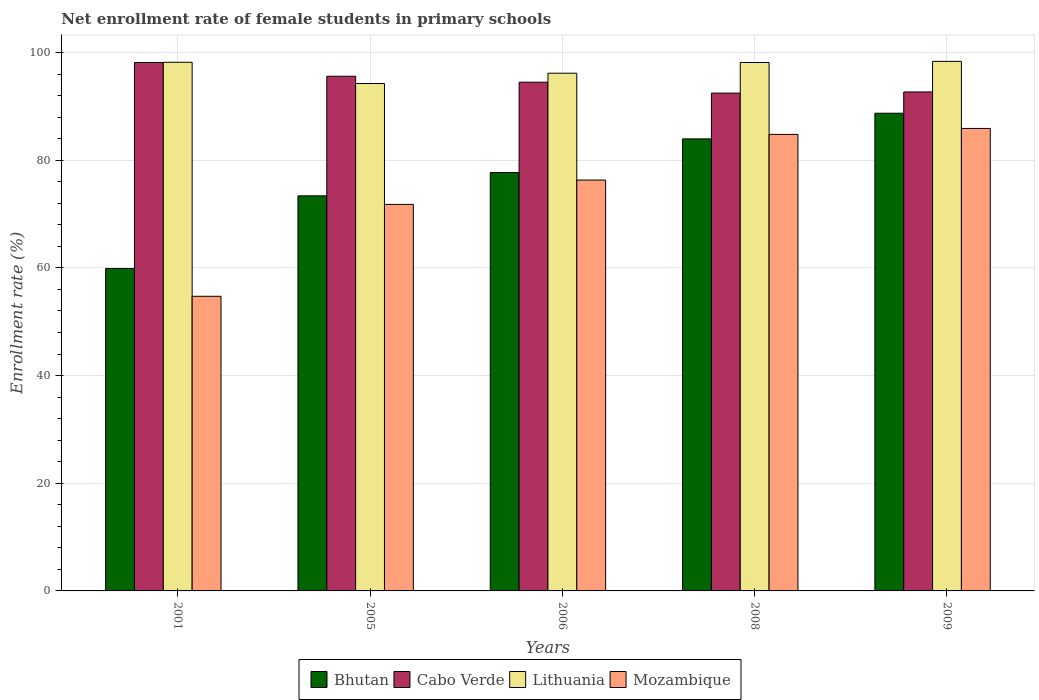How many groups of bars are there?
Provide a succinct answer. 5. What is the label of the 5th group of bars from the left?
Your response must be concise. 2009. What is the net enrollment rate of female students in primary schools in Bhutan in 2009?
Ensure brevity in your answer.  88.72. Across all years, what is the maximum net enrollment rate of female students in primary schools in Mozambique?
Your response must be concise. 85.89. Across all years, what is the minimum net enrollment rate of female students in primary schools in Mozambique?
Your answer should be very brief. 54.72. In which year was the net enrollment rate of female students in primary schools in Lithuania maximum?
Make the answer very short. 2009. In which year was the net enrollment rate of female students in primary schools in Cabo Verde minimum?
Your response must be concise. 2008. What is the total net enrollment rate of female students in primary schools in Mozambique in the graph?
Provide a succinct answer. 373.5. What is the difference between the net enrollment rate of female students in primary schools in Mozambique in 2001 and that in 2009?
Provide a short and direct response. -31.17. What is the difference between the net enrollment rate of female students in primary schools in Bhutan in 2009 and the net enrollment rate of female students in primary schools in Cabo Verde in 2006?
Your answer should be very brief. -5.76. What is the average net enrollment rate of female students in primary schools in Cabo Verde per year?
Provide a short and direct response. 94.67. In the year 2005, what is the difference between the net enrollment rate of female students in primary schools in Mozambique and net enrollment rate of female students in primary schools in Cabo Verde?
Give a very brief answer. -23.8. In how many years, is the net enrollment rate of female students in primary schools in Mozambique greater than 28 %?
Your response must be concise. 5. What is the ratio of the net enrollment rate of female students in primary schools in Cabo Verde in 2005 to that in 2008?
Keep it short and to the point. 1.03. Is the difference between the net enrollment rate of female students in primary schools in Mozambique in 2001 and 2006 greater than the difference between the net enrollment rate of female students in primary schools in Cabo Verde in 2001 and 2006?
Your answer should be compact. No. What is the difference between the highest and the second highest net enrollment rate of female students in primary schools in Bhutan?
Provide a succinct answer. 4.76. What is the difference between the highest and the lowest net enrollment rate of female students in primary schools in Mozambique?
Provide a short and direct response. 31.17. Is the sum of the net enrollment rate of female students in primary schools in Cabo Verde in 2001 and 2009 greater than the maximum net enrollment rate of female students in primary schools in Bhutan across all years?
Keep it short and to the point. Yes. What does the 2nd bar from the left in 2005 represents?
Offer a terse response. Cabo Verde. What does the 1st bar from the right in 2001 represents?
Make the answer very short. Mozambique. Are all the bars in the graph horizontal?
Offer a terse response. No. How many legend labels are there?
Your answer should be very brief. 4. How are the legend labels stacked?
Provide a short and direct response. Horizontal. What is the title of the graph?
Your answer should be compact. Net enrollment rate of female students in primary schools. Does "Croatia" appear as one of the legend labels in the graph?
Give a very brief answer. No. What is the label or title of the X-axis?
Offer a very short reply. Years. What is the label or title of the Y-axis?
Provide a succinct answer. Enrollment rate (%). What is the Enrollment rate (%) in Bhutan in 2001?
Provide a succinct answer. 59.88. What is the Enrollment rate (%) of Cabo Verde in 2001?
Give a very brief answer. 98.14. What is the Enrollment rate (%) of Lithuania in 2001?
Make the answer very short. 98.18. What is the Enrollment rate (%) in Mozambique in 2001?
Offer a very short reply. 54.72. What is the Enrollment rate (%) in Bhutan in 2005?
Your answer should be very brief. 73.38. What is the Enrollment rate (%) in Cabo Verde in 2005?
Give a very brief answer. 95.59. What is the Enrollment rate (%) of Lithuania in 2005?
Make the answer very short. 94.24. What is the Enrollment rate (%) of Mozambique in 2005?
Keep it short and to the point. 71.78. What is the Enrollment rate (%) of Bhutan in 2006?
Your response must be concise. 77.7. What is the Enrollment rate (%) of Cabo Verde in 2006?
Keep it short and to the point. 94.48. What is the Enrollment rate (%) in Lithuania in 2006?
Give a very brief answer. 96.15. What is the Enrollment rate (%) of Mozambique in 2006?
Your answer should be compact. 76.31. What is the Enrollment rate (%) of Bhutan in 2008?
Your response must be concise. 83.95. What is the Enrollment rate (%) of Cabo Verde in 2008?
Your answer should be very brief. 92.46. What is the Enrollment rate (%) in Lithuania in 2008?
Your answer should be compact. 98.14. What is the Enrollment rate (%) in Mozambique in 2008?
Offer a terse response. 84.79. What is the Enrollment rate (%) of Bhutan in 2009?
Provide a short and direct response. 88.72. What is the Enrollment rate (%) in Cabo Verde in 2009?
Provide a succinct answer. 92.67. What is the Enrollment rate (%) in Lithuania in 2009?
Offer a terse response. 98.35. What is the Enrollment rate (%) of Mozambique in 2009?
Make the answer very short. 85.89. Across all years, what is the maximum Enrollment rate (%) of Bhutan?
Ensure brevity in your answer.  88.72. Across all years, what is the maximum Enrollment rate (%) of Cabo Verde?
Provide a succinct answer. 98.14. Across all years, what is the maximum Enrollment rate (%) of Lithuania?
Your response must be concise. 98.35. Across all years, what is the maximum Enrollment rate (%) in Mozambique?
Keep it short and to the point. 85.89. Across all years, what is the minimum Enrollment rate (%) in Bhutan?
Keep it short and to the point. 59.88. Across all years, what is the minimum Enrollment rate (%) of Cabo Verde?
Offer a very short reply. 92.46. Across all years, what is the minimum Enrollment rate (%) of Lithuania?
Keep it short and to the point. 94.24. Across all years, what is the minimum Enrollment rate (%) in Mozambique?
Provide a succinct answer. 54.72. What is the total Enrollment rate (%) in Bhutan in the graph?
Offer a terse response. 383.63. What is the total Enrollment rate (%) in Cabo Verde in the graph?
Provide a succinct answer. 473.34. What is the total Enrollment rate (%) in Lithuania in the graph?
Your answer should be very brief. 485.06. What is the total Enrollment rate (%) in Mozambique in the graph?
Your response must be concise. 373.5. What is the difference between the Enrollment rate (%) in Bhutan in 2001 and that in 2005?
Offer a terse response. -13.5. What is the difference between the Enrollment rate (%) in Cabo Verde in 2001 and that in 2005?
Keep it short and to the point. 2.55. What is the difference between the Enrollment rate (%) in Lithuania in 2001 and that in 2005?
Keep it short and to the point. 3.94. What is the difference between the Enrollment rate (%) in Mozambique in 2001 and that in 2005?
Ensure brevity in your answer.  -17.06. What is the difference between the Enrollment rate (%) in Bhutan in 2001 and that in 2006?
Give a very brief answer. -17.82. What is the difference between the Enrollment rate (%) in Cabo Verde in 2001 and that in 2006?
Your response must be concise. 3.66. What is the difference between the Enrollment rate (%) in Lithuania in 2001 and that in 2006?
Keep it short and to the point. 2.03. What is the difference between the Enrollment rate (%) in Mozambique in 2001 and that in 2006?
Offer a very short reply. -21.59. What is the difference between the Enrollment rate (%) of Bhutan in 2001 and that in 2008?
Provide a short and direct response. -24.08. What is the difference between the Enrollment rate (%) in Cabo Verde in 2001 and that in 2008?
Provide a succinct answer. 5.68. What is the difference between the Enrollment rate (%) of Lithuania in 2001 and that in 2008?
Offer a terse response. 0.04. What is the difference between the Enrollment rate (%) of Mozambique in 2001 and that in 2008?
Offer a terse response. -30.07. What is the difference between the Enrollment rate (%) of Bhutan in 2001 and that in 2009?
Make the answer very short. -28.84. What is the difference between the Enrollment rate (%) of Cabo Verde in 2001 and that in 2009?
Ensure brevity in your answer.  5.47. What is the difference between the Enrollment rate (%) in Lithuania in 2001 and that in 2009?
Offer a terse response. -0.17. What is the difference between the Enrollment rate (%) in Mozambique in 2001 and that in 2009?
Your answer should be very brief. -31.17. What is the difference between the Enrollment rate (%) of Bhutan in 2005 and that in 2006?
Your response must be concise. -4.32. What is the difference between the Enrollment rate (%) in Cabo Verde in 2005 and that in 2006?
Your answer should be compact. 1.11. What is the difference between the Enrollment rate (%) of Lithuania in 2005 and that in 2006?
Keep it short and to the point. -1.91. What is the difference between the Enrollment rate (%) in Mozambique in 2005 and that in 2006?
Give a very brief answer. -4.52. What is the difference between the Enrollment rate (%) of Bhutan in 2005 and that in 2008?
Make the answer very short. -10.58. What is the difference between the Enrollment rate (%) of Cabo Verde in 2005 and that in 2008?
Ensure brevity in your answer.  3.13. What is the difference between the Enrollment rate (%) in Lithuania in 2005 and that in 2008?
Provide a short and direct response. -3.9. What is the difference between the Enrollment rate (%) of Mozambique in 2005 and that in 2008?
Your answer should be very brief. -13.01. What is the difference between the Enrollment rate (%) of Bhutan in 2005 and that in 2009?
Your answer should be very brief. -15.34. What is the difference between the Enrollment rate (%) in Cabo Verde in 2005 and that in 2009?
Your response must be concise. 2.91. What is the difference between the Enrollment rate (%) in Lithuania in 2005 and that in 2009?
Make the answer very short. -4.12. What is the difference between the Enrollment rate (%) in Mozambique in 2005 and that in 2009?
Offer a terse response. -14.11. What is the difference between the Enrollment rate (%) in Bhutan in 2006 and that in 2008?
Give a very brief answer. -6.25. What is the difference between the Enrollment rate (%) in Cabo Verde in 2006 and that in 2008?
Make the answer very short. 2.02. What is the difference between the Enrollment rate (%) of Lithuania in 2006 and that in 2008?
Provide a short and direct response. -1.99. What is the difference between the Enrollment rate (%) of Mozambique in 2006 and that in 2008?
Your answer should be compact. -8.48. What is the difference between the Enrollment rate (%) of Bhutan in 2006 and that in 2009?
Make the answer very short. -11.02. What is the difference between the Enrollment rate (%) of Cabo Verde in 2006 and that in 2009?
Give a very brief answer. 1.81. What is the difference between the Enrollment rate (%) of Lithuania in 2006 and that in 2009?
Keep it short and to the point. -2.2. What is the difference between the Enrollment rate (%) of Mozambique in 2006 and that in 2009?
Ensure brevity in your answer.  -9.59. What is the difference between the Enrollment rate (%) of Bhutan in 2008 and that in 2009?
Keep it short and to the point. -4.76. What is the difference between the Enrollment rate (%) in Cabo Verde in 2008 and that in 2009?
Provide a succinct answer. -0.22. What is the difference between the Enrollment rate (%) of Lithuania in 2008 and that in 2009?
Your response must be concise. -0.21. What is the difference between the Enrollment rate (%) in Mozambique in 2008 and that in 2009?
Keep it short and to the point. -1.1. What is the difference between the Enrollment rate (%) of Bhutan in 2001 and the Enrollment rate (%) of Cabo Verde in 2005?
Make the answer very short. -35.71. What is the difference between the Enrollment rate (%) of Bhutan in 2001 and the Enrollment rate (%) of Lithuania in 2005?
Your answer should be very brief. -34.36. What is the difference between the Enrollment rate (%) of Bhutan in 2001 and the Enrollment rate (%) of Mozambique in 2005?
Keep it short and to the point. -11.91. What is the difference between the Enrollment rate (%) in Cabo Verde in 2001 and the Enrollment rate (%) in Lithuania in 2005?
Provide a succinct answer. 3.9. What is the difference between the Enrollment rate (%) in Cabo Verde in 2001 and the Enrollment rate (%) in Mozambique in 2005?
Your response must be concise. 26.36. What is the difference between the Enrollment rate (%) of Lithuania in 2001 and the Enrollment rate (%) of Mozambique in 2005?
Your answer should be very brief. 26.4. What is the difference between the Enrollment rate (%) of Bhutan in 2001 and the Enrollment rate (%) of Cabo Verde in 2006?
Offer a very short reply. -34.6. What is the difference between the Enrollment rate (%) of Bhutan in 2001 and the Enrollment rate (%) of Lithuania in 2006?
Your answer should be compact. -36.27. What is the difference between the Enrollment rate (%) in Bhutan in 2001 and the Enrollment rate (%) in Mozambique in 2006?
Offer a terse response. -16.43. What is the difference between the Enrollment rate (%) of Cabo Verde in 2001 and the Enrollment rate (%) of Lithuania in 2006?
Your response must be concise. 1.99. What is the difference between the Enrollment rate (%) of Cabo Verde in 2001 and the Enrollment rate (%) of Mozambique in 2006?
Ensure brevity in your answer.  21.83. What is the difference between the Enrollment rate (%) in Lithuania in 2001 and the Enrollment rate (%) in Mozambique in 2006?
Provide a short and direct response. 21.87. What is the difference between the Enrollment rate (%) in Bhutan in 2001 and the Enrollment rate (%) in Cabo Verde in 2008?
Provide a succinct answer. -32.58. What is the difference between the Enrollment rate (%) of Bhutan in 2001 and the Enrollment rate (%) of Lithuania in 2008?
Offer a very short reply. -38.26. What is the difference between the Enrollment rate (%) of Bhutan in 2001 and the Enrollment rate (%) of Mozambique in 2008?
Your response must be concise. -24.91. What is the difference between the Enrollment rate (%) of Cabo Verde in 2001 and the Enrollment rate (%) of Lithuania in 2008?
Your response must be concise. -0. What is the difference between the Enrollment rate (%) in Cabo Verde in 2001 and the Enrollment rate (%) in Mozambique in 2008?
Your answer should be very brief. 13.35. What is the difference between the Enrollment rate (%) of Lithuania in 2001 and the Enrollment rate (%) of Mozambique in 2008?
Ensure brevity in your answer.  13.39. What is the difference between the Enrollment rate (%) of Bhutan in 2001 and the Enrollment rate (%) of Cabo Verde in 2009?
Your answer should be compact. -32.8. What is the difference between the Enrollment rate (%) in Bhutan in 2001 and the Enrollment rate (%) in Lithuania in 2009?
Offer a terse response. -38.48. What is the difference between the Enrollment rate (%) in Bhutan in 2001 and the Enrollment rate (%) in Mozambique in 2009?
Ensure brevity in your answer.  -26.02. What is the difference between the Enrollment rate (%) of Cabo Verde in 2001 and the Enrollment rate (%) of Lithuania in 2009?
Your response must be concise. -0.21. What is the difference between the Enrollment rate (%) in Cabo Verde in 2001 and the Enrollment rate (%) in Mozambique in 2009?
Provide a succinct answer. 12.25. What is the difference between the Enrollment rate (%) of Lithuania in 2001 and the Enrollment rate (%) of Mozambique in 2009?
Provide a succinct answer. 12.29. What is the difference between the Enrollment rate (%) of Bhutan in 2005 and the Enrollment rate (%) of Cabo Verde in 2006?
Your answer should be very brief. -21.1. What is the difference between the Enrollment rate (%) in Bhutan in 2005 and the Enrollment rate (%) in Lithuania in 2006?
Your response must be concise. -22.77. What is the difference between the Enrollment rate (%) of Bhutan in 2005 and the Enrollment rate (%) of Mozambique in 2006?
Make the answer very short. -2.93. What is the difference between the Enrollment rate (%) of Cabo Verde in 2005 and the Enrollment rate (%) of Lithuania in 2006?
Give a very brief answer. -0.56. What is the difference between the Enrollment rate (%) in Cabo Verde in 2005 and the Enrollment rate (%) in Mozambique in 2006?
Make the answer very short. 19.28. What is the difference between the Enrollment rate (%) in Lithuania in 2005 and the Enrollment rate (%) in Mozambique in 2006?
Provide a short and direct response. 17.93. What is the difference between the Enrollment rate (%) of Bhutan in 2005 and the Enrollment rate (%) of Cabo Verde in 2008?
Ensure brevity in your answer.  -19.08. What is the difference between the Enrollment rate (%) in Bhutan in 2005 and the Enrollment rate (%) in Lithuania in 2008?
Keep it short and to the point. -24.76. What is the difference between the Enrollment rate (%) of Bhutan in 2005 and the Enrollment rate (%) of Mozambique in 2008?
Give a very brief answer. -11.41. What is the difference between the Enrollment rate (%) of Cabo Verde in 2005 and the Enrollment rate (%) of Lithuania in 2008?
Your answer should be very brief. -2.55. What is the difference between the Enrollment rate (%) of Cabo Verde in 2005 and the Enrollment rate (%) of Mozambique in 2008?
Provide a succinct answer. 10.8. What is the difference between the Enrollment rate (%) in Lithuania in 2005 and the Enrollment rate (%) in Mozambique in 2008?
Your answer should be very brief. 9.45. What is the difference between the Enrollment rate (%) in Bhutan in 2005 and the Enrollment rate (%) in Cabo Verde in 2009?
Your answer should be very brief. -19.3. What is the difference between the Enrollment rate (%) in Bhutan in 2005 and the Enrollment rate (%) in Lithuania in 2009?
Give a very brief answer. -24.98. What is the difference between the Enrollment rate (%) of Bhutan in 2005 and the Enrollment rate (%) of Mozambique in 2009?
Provide a succinct answer. -12.51. What is the difference between the Enrollment rate (%) in Cabo Verde in 2005 and the Enrollment rate (%) in Lithuania in 2009?
Give a very brief answer. -2.77. What is the difference between the Enrollment rate (%) in Cabo Verde in 2005 and the Enrollment rate (%) in Mozambique in 2009?
Offer a very short reply. 9.7. What is the difference between the Enrollment rate (%) of Lithuania in 2005 and the Enrollment rate (%) of Mozambique in 2009?
Provide a succinct answer. 8.35. What is the difference between the Enrollment rate (%) in Bhutan in 2006 and the Enrollment rate (%) in Cabo Verde in 2008?
Make the answer very short. -14.75. What is the difference between the Enrollment rate (%) in Bhutan in 2006 and the Enrollment rate (%) in Lithuania in 2008?
Offer a terse response. -20.44. What is the difference between the Enrollment rate (%) of Bhutan in 2006 and the Enrollment rate (%) of Mozambique in 2008?
Give a very brief answer. -7.09. What is the difference between the Enrollment rate (%) in Cabo Verde in 2006 and the Enrollment rate (%) in Lithuania in 2008?
Keep it short and to the point. -3.66. What is the difference between the Enrollment rate (%) in Cabo Verde in 2006 and the Enrollment rate (%) in Mozambique in 2008?
Your answer should be very brief. 9.69. What is the difference between the Enrollment rate (%) in Lithuania in 2006 and the Enrollment rate (%) in Mozambique in 2008?
Offer a terse response. 11.36. What is the difference between the Enrollment rate (%) of Bhutan in 2006 and the Enrollment rate (%) of Cabo Verde in 2009?
Keep it short and to the point. -14.97. What is the difference between the Enrollment rate (%) of Bhutan in 2006 and the Enrollment rate (%) of Lithuania in 2009?
Your response must be concise. -20.65. What is the difference between the Enrollment rate (%) in Bhutan in 2006 and the Enrollment rate (%) in Mozambique in 2009?
Your response must be concise. -8.19. What is the difference between the Enrollment rate (%) of Cabo Verde in 2006 and the Enrollment rate (%) of Lithuania in 2009?
Offer a terse response. -3.87. What is the difference between the Enrollment rate (%) in Cabo Verde in 2006 and the Enrollment rate (%) in Mozambique in 2009?
Make the answer very short. 8.59. What is the difference between the Enrollment rate (%) in Lithuania in 2006 and the Enrollment rate (%) in Mozambique in 2009?
Provide a succinct answer. 10.26. What is the difference between the Enrollment rate (%) in Bhutan in 2008 and the Enrollment rate (%) in Cabo Verde in 2009?
Provide a succinct answer. -8.72. What is the difference between the Enrollment rate (%) of Bhutan in 2008 and the Enrollment rate (%) of Lithuania in 2009?
Provide a short and direct response. -14.4. What is the difference between the Enrollment rate (%) in Bhutan in 2008 and the Enrollment rate (%) in Mozambique in 2009?
Your response must be concise. -1.94. What is the difference between the Enrollment rate (%) of Cabo Verde in 2008 and the Enrollment rate (%) of Lithuania in 2009?
Provide a short and direct response. -5.9. What is the difference between the Enrollment rate (%) of Cabo Verde in 2008 and the Enrollment rate (%) of Mozambique in 2009?
Your response must be concise. 6.56. What is the difference between the Enrollment rate (%) in Lithuania in 2008 and the Enrollment rate (%) in Mozambique in 2009?
Your response must be concise. 12.25. What is the average Enrollment rate (%) in Bhutan per year?
Provide a succinct answer. 76.73. What is the average Enrollment rate (%) of Cabo Verde per year?
Offer a very short reply. 94.67. What is the average Enrollment rate (%) in Lithuania per year?
Offer a very short reply. 97.01. What is the average Enrollment rate (%) in Mozambique per year?
Provide a short and direct response. 74.7. In the year 2001, what is the difference between the Enrollment rate (%) of Bhutan and Enrollment rate (%) of Cabo Verde?
Offer a very short reply. -38.26. In the year 2001, what is the difference between the Enrollment rate (%) in Bhutan and Enrollment rate (%) in Lithuania?
Offer a terse response. -38.3. In the year 2001, what is the difference between the Enrollment rate (%) of Bhutan and Enrollment rate (%) of Mozambique?
Provide a succinct answer. 5.16. In the year 2001, what is the difference between the Enrollment rate (%) in Cabo Verde and Enrollment rate (%) in Lithuania?
Keep it short and to the point. -0.04. In the year 2001, what is the difference between the Enrollment rate (%) of Cabo Verde and Enrollment rate (%) of Mozambique?
Offer a terse response. 43.42. In the year 2001, what is the difference between the Enrollment rate (%) of Lithuania and Enrollment rate (%) of Mozambique?
Provide a succinct answer. 43.46. In the year 2005, what is the difference between the Enrollment rate (%) of Bhutan and Enrollment rate (%) of Cabo Verde?
Keep it short and to the point. -22.21. In the year 2005, what is the difference between the Enrollment rate (%) in Bhutan and Enrollment rate (%) in Lithuania?
Ensure brevity in your answer.  -20.86. In the year 2005, what is the difference between the Enrollment rate (%) of Bhutan and Enrollment rate (%) of Mozambique?
Keep it short and to the point. 1.59. In the year 2005, what is the difference between the Enrollment rate (%) in Cabo Verde and Enrollment rate (%) in Lithuania?
Offer a very short reply. 1.35. In the year 2005, what is the difference between the Enrollment rate (%) of Cabo Verde and Enrollment rate (%) of Mozambique?
Offer a very short reply. 23.8. In the year 2005, what is the difference between the Enrollment rate (%) in Lithuania and Enrollment rate (%) in Mozambique?
Keep it short and to the point. 22.45. In the year 2006, what is the difference between the Enrollment rate (%) in Bhutan and Enrollment rate (%) in Cabo Verde?
Provide a succinct answer. -16.78. In the year 2006, what is the difference between the Enrollment rate (%) in Bhutan and Enrollment rate (%) in Lithuania?
Your response must be concise. -18.45. In the year 2006, what is the difference between the Enrollment rate (%) in Bhutan and Enrollment rate (%) in Mozambique?
Provide a short and direct response. 1.39. In the year 2006, what is the difference between the Enrollment rate (%) of Cabo Verde and Enrollment rate (%) of Lithuania?
Ensure brevity in your answer.  -1.67. In the year 2006, what is the difference between the Enrollment rate (%) in Cabo Verde and Enrollment rate (%) in Mozambique?
Your answer should be compact. 18.17. In the year 2006, what is the difference between the Enrollment rate (%) of Lithuania and Enrollment rate (%) of Mozambique?
Provide a succinct answer. 19.84. In the year 2008, what is the difference between the Enrollment rate (%) in Bhutan and Enrollment rate (%) in Cabo Verde?
Your answer should be very brief. -8.5. In the year 2008, what is the difference between the Enrollment rate (%) of Bhutan and Enrollment rate (%) of Lithuania?
Keep it short and to the point. -14.19. In the year 2008, what is the difference between the Enrollment rate (%) in Bhutan and Enrollment rate (%) in Mozambique?
Give a very brief answer. -0.83. In the year 2008, what is the difference between the Enrollment rate (%) of Cabo Verde and Enrollment rate (%) of Lithuania?
Keep it short and to the point. -5.68. In the year 2008, what is the difference between the Enrollment rate (%) of Cabo Verde and Enrollment rate (%) of Mozambique?
Keep it short and to the point. 7.67. In the year 2008, what is the difference between the Enrollment rate (%) of Lithuania and Enrollment rate (%) of Mozambique?
Offer a terse response. 13.35. In the year 2009, what is the difference between the Enrollment rate (%) in Bhutan and Enrollment rate (%) in Cabo Verde?
Provide a succinct answer. -3.95. In the year 2009, what is the difference between the Enrollment rate (%) in Bhutan and Enrollment rate (%) in Lithuania?
Your answer should be compact. -9.63. In the year 2009, what is the difference between the Enrollment rate (%) in Bhutan and Enrollment rate (%) in Mozambique?
Provide a succinct answer. 2.83. In the year 2009, what is the difference between the Enrollment rate (%) of Cabo Verde and Enrollment rate (%) of Lithuania?
Keep it short and to the point. -5.68. In the year 2009, what is the difference between the Enrollment rate (%) of Cabo Verde and Enrollment rate (%) of Mozambique?
Offer a very short reply. 6.78. In the year 2009, what is the difference between the Enrollment rate (%) of Lithuania and Enrollment rate (%) of Mozambique?
Offer a terse response. 12.46. What is the ratio of the Enrollment rate (%) in Bhutan in 2001 to that in 2005?
Offer a very short reply. 0.82. What is the ratio of the Enrollment rate (%) of Cabo Verde in 2001 to that in 2005?
Your answer should be very brief. 1.03. What is the ratio of the Enrollment rate (%) in Lithuania in 2001 to that in 2005?
Provide a short and direct response. 1.04. What is the ratio of the Enrollment rate (%) in Mozambique in 2001 to that in 2005?
Provide a short and direct response. 0.76. What is the ratio of the Enrollment rate (%) of Bhutan in 2001 to that in 2006?
Your response must be concise. 0.77. What is the ratio of the Enrollment rate (%) of Cabo Verde in 2001 to that in 2006?
Offer a very short reply. 1.04. What is the ratio of the Enrollment rate (%) of Lithuania in 2001 to that in 2006?
Offer a terse response. 1.02. What is the ratio of the Enrollment rate (%) of Mozambique in 2001 to that in 2006?
Your response must be concise. 0.72. What is the ratio of the Enrollment rate (%) in Bhutan in 2001 to that in 2008?
Offer a very short reply. 0.71. What is the ratio of the Enrollment rate (%) in Cabo Verde in 2001 to that in 2008?
Provide a succinct answer. 1.06. What is the ratio of the Enrollment rate (%) in Mozambique in 2001 to that in 2008?
Your answer should be compact. 0.65. What is the ratio of the Enrollment rate (%) in Bhutan in 2001 to that in 2009?
Your answer should be very brief. 0.67. What is the ratio of the Enrollment rate (%) in Cabo Verde in 2001 to that in 2009?
Give a very brief answer. 1.06. What is the ratio of the Enrollment rate (%) in Mozambique in 2001 to that in 2009?
Your response must be concise. 0.64. What is the ratio of the Enrollment rate (%) in Bhutan in 2005 to that in 2006?
Offer a very short reply. 0.94. What is the ratio of the Enrollment rate (%) in Cabo Verde in 2005 to that in 2006?
Your answer should be very brief. 1.01. What is the ratio of the Enrollment rate (%) of Lithuania in 2005 to that in 2006?
Offer a very short reply. 0.98. What is the ratio of the Enrollment rate (%) of Mozambique in 2005 to that in 2006?
Provide a short and direct response. 0.94. What is the ratio of the Enrollment rate (%) of Bhutan in 2005 to that in 2008?
Your answer should be very brief. 0.87. What is the ratio of the Enrollment rate (%) in Cabo Verde in 2005 to that in 2008?
Offer a terse response. 1.03. What is the ratio of the Enrollment rate (%) in Lithuania in 2005 to that in 2008?
Give a very brief answer. 0.96. What is the ratio of the Enrollment rate (%) in Mozambique in 2005 to that in 2008?
Provide a succinct answer. 0.85. What is the ratio of the Enrollment rate (%) in Bhutan in 2005 to that in 2009?
Offer a terse response. 0.83. What is the ratio of the Enrollment rate (%) of Cabo Verde in 2005 to that in 2009?
Your response must be concise. 1.03. What is the ratio of the Enrollment rate (%) in Lithuania in 2005 to that in 2009?
Offer a terse response. 0.96. What is the ratio of the Enrollment rate (%) in Mozambique in 2005 to that in 2009?
Ensure brevity in your answer.  0.84. What is the ratio of the Enrollment rate (%) of Bhutan in 2006 to that in 2008?
Ensure brevity in your answer.  0.93. What is the ratio of the Enrollment rate (%) in Cabo Verde in 2006 to that in 2008?
Offer a very short reply. 1.02. What is the ratio of the Enrollment rate (%) of Lithuania in 2006 to that in 2008?
Offer a very short reply. 0.98. What is the ratio of the Enrollment rate (%) in Bhutan in 2006 to that in 2009?
Provide a short and direct response. 0.88. What is the ratio of the Enrollment rate (%) in Cabo Verde in 2006 to that in 2009?
Ensure brevity in your answer.  1.02. What is the ratio of the Enrollment rate (%) in Lithuania in 2006 to that in 2009?
Keep it short and to the point. 0.98. What is the ratio of the Enrollment rate (%) of Mozambique in 2006 to that in 2009?
Your answer should be compact. 0.89. What is the ratio of the Enrollment rate (%) in Bhutan in 2008 to that in 2009?
Provide a short and direct response. 0.95. What is the ratio of the Enrollment rate (%) of Mozambique in 2008 to that in 2009?
Your response must be concise. 0.99. What is the difference between the highest and the second highest Enrollment rate (%) of Bhutan?
Your answer should be compact. 4.76. What is the difference between the highest and the second highest Enrollment rate (%) in Cabo Verde?
Offer a very short reply. 2.55. What is the difference between the highest and the second highest Enrollment rate (%) in Lithuania?
Make the answer very short. 0.17. What is the difference between the highest and the second highest Enrollment rate (%) in Mozambique?
Your answer should be very brief. 1.1. What is the difference between the highest and the lowest Enrollment rate (%) of Bhutan?
Provide a short and direct response. 28.84. What is the difference between the highest and the lowest Enrollment rate (%) of Cabo Verde?
Ensure brevity in your answer.  5.68. What is the difference between the highest and the lowest Enrollment rate (%) of Lithuania?
Your answer should be compact. 4.12. What is the difference between the highest and the lowest Enrollment rate (%) of Mozambique?
Provide a succinct answer. 31.17. 